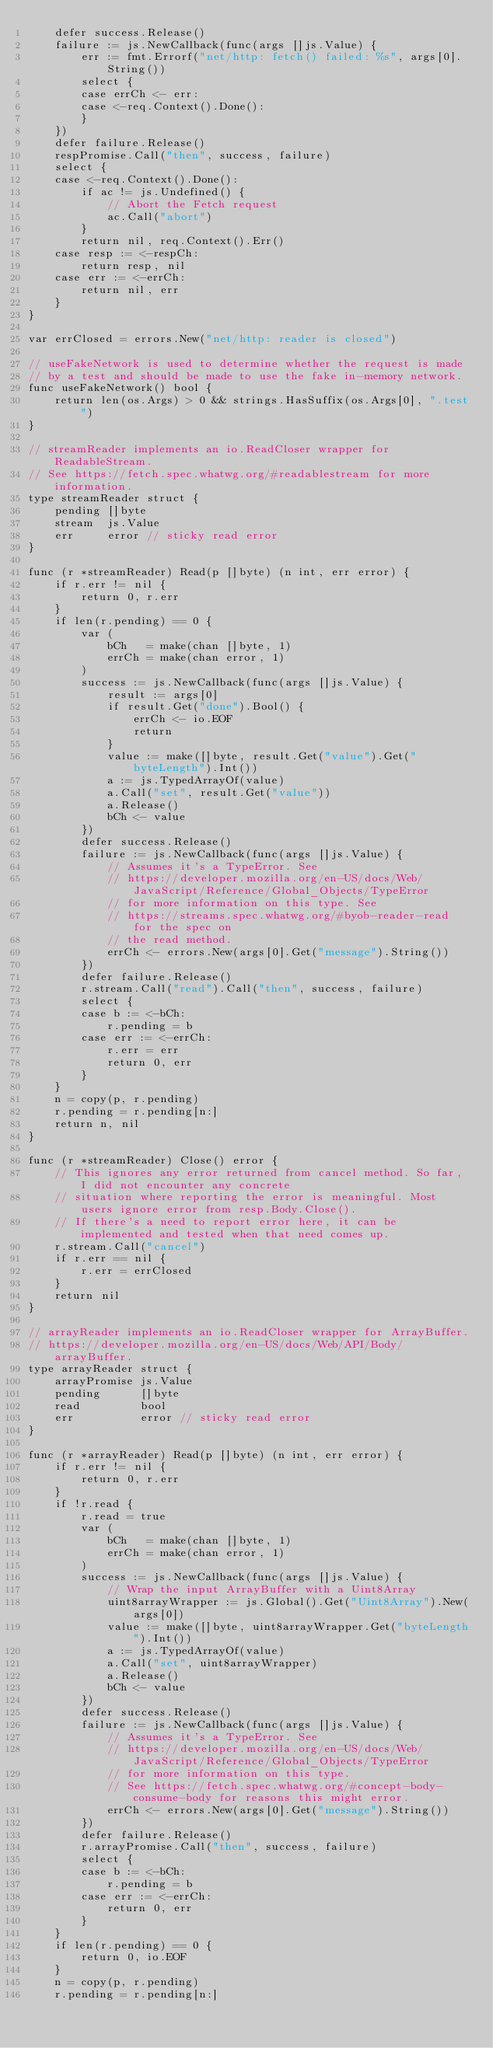Convert code to text. <code><loc_0><loc_0><loc_500><loc_500><_Go_>	defer success.Release()
	failure := js.NewCallback(func(args []js.Value) {
		err := fmt.Errorf("net/http: fetch() failed: %s", args[0].String())
		select {
		case errCh <- err:
		case <-req.Context().Done():
		}
	})
	defer failure.Release()
	respPromise.Call("then", success, failure)
	select {
	case <-req.Context().Done():
		if ac != js.Undefined() {
			// Abort the Fetch request
			ac.Call("abort")
		}
		return nil, req.Context().Err()
	case resp := <-respCh:
		return resp, nil
	case err := <-errCh:
		return nil, err
	}
}

var errClosed = errors.New("net/http: reader is closed")

// useFakeNetwork is used to determine whether the request is made
// by a test and should be made to use the fake in-memory network.
func useFakeNetwork() bool {
	return len(os.Args) > 0 && strings.HasSuffix(os.Args[0], ".test")
}

// streamReader implements an io.ReadCloser wrapper for ReadableStream.
// See https://fetch.spec.whatwg.org/#readablestream for more information.
type streamReader struct {
	pending []byte
	stream  js.Value
	err     error // sticky read error
}

func (r *streamReader) Read(p []byte) (n int, err error) {
	if r.err != nil {
		return 0, r.err
	}
	if len(r.pending) == 0 {
		var (
			bCh   = make(chan []byte, 1)
			errCh = make(chan error, 1)
		)
		success := js.NewCallback(func(args []js.Value) {
			result := args[0]
			if result.Get("done").Bool() {
				errCh <- io.EOF
				return
			}
			value := make([]byte, result.Get("value").Get("byteLength").Int())
			a := js.TypedArrayOf(value)
			a.Call("set", result.Get("value"))
			a.Release()
			bCh <- value
		})
		defer success.Release()
		failure := js.NewCallback(func(args []js.Value) {
			// Assumes it's a TypeError. See
			// https://developer.mozilla.org/en-US/docs/Web/JavaScript/Reference/Global_Objects/TypeError
			// for more information on this type. See
			// https://streams.spec.whatwg.org/#byob-reader-read for the spec on
			// the read method.
			errCh <- errors.New(args[0].Get("message").String())
		})
		defer failure.Release()
		r.stream.Call("read").Call("then", success, failure)
		select {
		case b := <-bCh:
			r.pending = b
		case err := <-errCh:
			r.err = err
			return 0, err
		}
	}
	n = copy(p, r.pending)
	r.pending = r.pending[n:]
	return n, nil
}

func (r *streamReader) Close() error {
	// This ignores any error returned from cancel method. So far, I did not encounter any concrete
	// situation where reporting the error is meaningful. Most users ignore error from resp.Body.Close().
	// If there's a need to report error here, it can be implemented and tested when that need comes up.
	r.stream.Call("cancel")
	if r.err == nil {
		r.err = errClosed
	}
	return nil
}

// arrayReader implements an io.ReadCloser wrapper for ArrayBuffer.
// https://developer.mozilla.org/en-US/docs/Web/API/Body/arrayBuffer.
type arrayReader struct {
	arrayPromise js.Value
	pending      []byte
	read         bool
	err          error // sticky read error
}

func (r *arrayReader) Read(p []byte) (n int, err error) {
	if r.err != nil {
		return 0, r.err
	}
	if !r.read {
		r.read = true
		var (
			bCh   = make(chan []byte, 1)
			errCh = make(chan error, 1)
		)
		success := js.NewCallback(func(args []js.Value) {
			// Wrap the input ArrayBuffer with a Uint8Array
			uint8arrayWrapper := js.Global().Get("Uint8Array").New(args[0])
			value := make([]byte, uint8arrayWrapper.Get("byteLength").Int())
			a := js.TypedArrayOf(value)
			a.Call("set", uint8arrayWrapper)
			a.Release()
			bCh <- value
		})
		defer success.Release()
		failure := js.NewCallback(func(args []js.Value) {
			// Assumes it's a TypeError. See
			// https://developer.mozilla.org/en-US/docs/Web/JavaScript/Reference/Global_Objects/TypeError
			// for more information on this type.
			// See https://fetch.spec.whatwg.org/#concept-body-consume-body for reasons this might error.
			errCh <- errors.New(args[0].Get("message").String())
		})
		defer failure.Release()
		r.arrayPromise.Call("then", success, failure)
		select {
		case b := <-bCh:
			r.pending = b
		case err := <-errCh:
			return 0, err
		}
	}
	if len(r.pending) == 0 {
		return 0, io.EOF
	}
	n = copy(p, r.pending)
	r.pending = r.pending[n:]</code> 